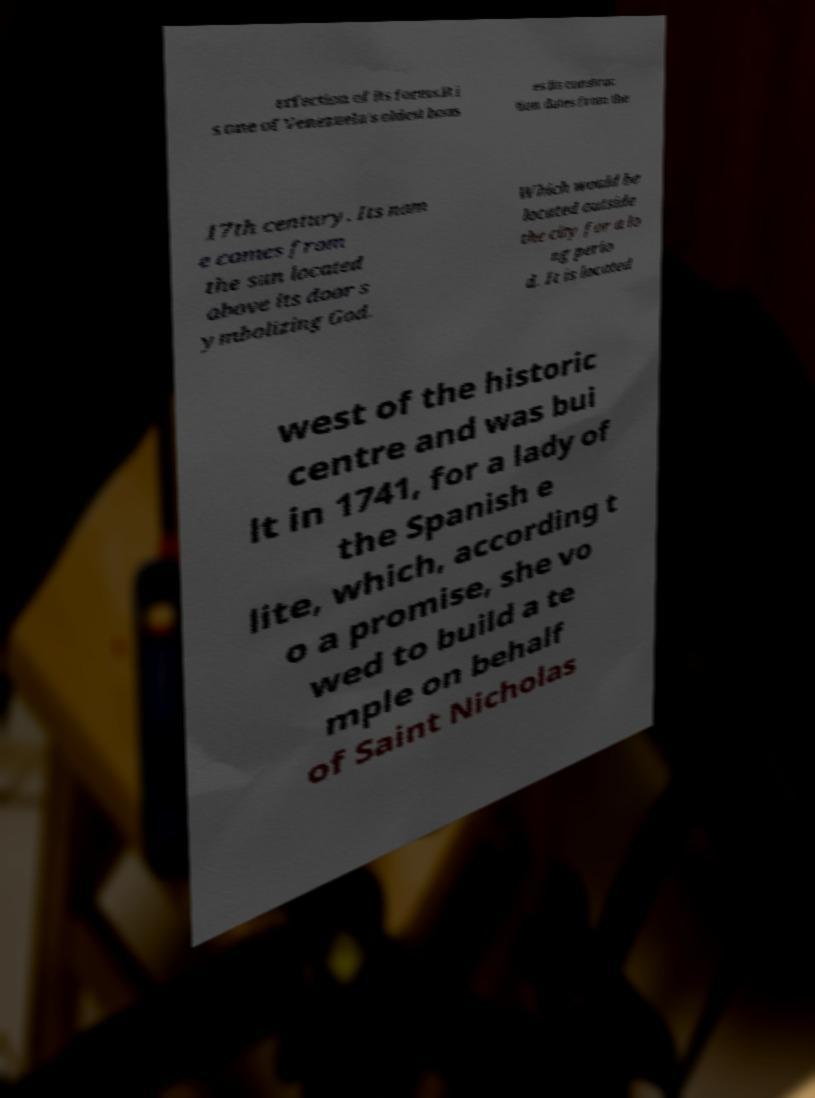For documentation purposes, I need the text within this image transcribed. Could you provide that? erfection of its forms.It i s one of Venezuela's oldest hous es its construc tion dates from the 17th century. Its nam e comes from the sun located above its door s ymbolizing God. Which would be located outside the city for a lo ng perio d. It is located west of the historic centre and was bui lt in 1741, for a lady of the Spanish e lite, which, according t o a promise, she vo wed to build a te mple on behalf of Saint Nicholas 